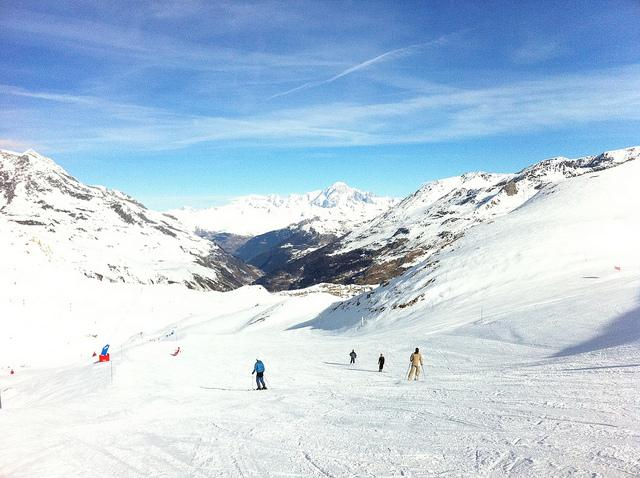What type of sport is this? Please explain your reasoning. winter. The ground is covered in snow. 